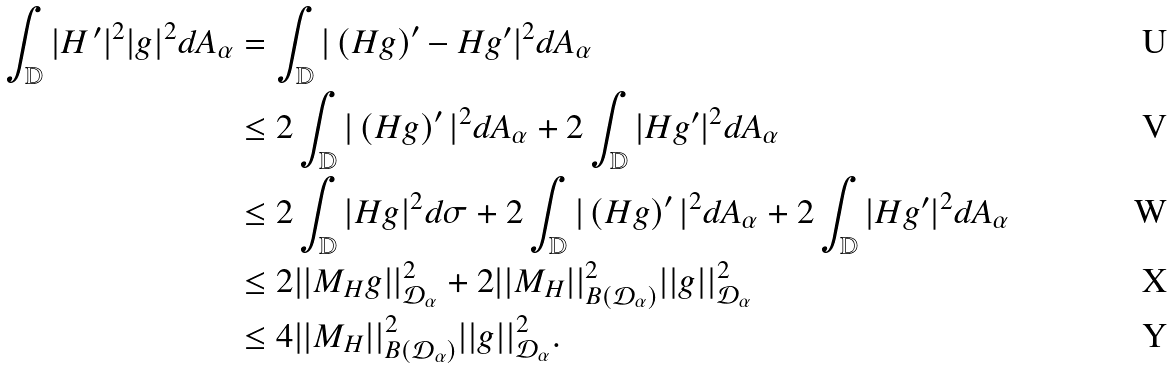<formula> <loc_0><loc_0><loc_500><loc_500>\int _ { \mathbb { D } } | H \, ^ { \prime } | ^ { 2 } | g | ^ { 2 } d A _ { \alpha } & = \int _ { \mathbb { D } } | \left ( H g \right ) ^ { \prime } - H g ^ { \prime } | ^ { 2 } d A _ { \alpha } \\ & \leq 2 \int _ { \mathbb { D } } | \left ( H g \right ) ^ { \prime } | ^ { 2 } d A _ { \alpha } + 2 \int _ { \mathbb { D } } | H g ^ { \prime } | ^ { 2 } d A _ { \alpha } \\ & \leq 2 \int _ { \mathbb { D } } | H g | ^ { 2 } d \sigma + 2 \int _ { \mathbb { D } } | \left ( H g \right ) ^ { \prime } | ^ { 2 } d A _ { \alpha } + 2 \int _ { \mathbb { D } } | H g ^ { \prime } | ^ { 2 } d A _ { \alpha } \\ & \leq 2 | | M _ { H } g | | _ { \mathcal { D } _ { \alpha } } ^ { 2 } + 2 | | M _ { H } | | _ { B \left ( \mathcal { D } _ { \alpha } \right ) } ^ { 2 } | | g | | _ { \mathcal { D } _ { \alpha } } ^ { 2 } \\ & \leq 4 | | M _ { H } | | _ { B \left ( \mathcal { D } _ { \alpha } \right ) } ^ { 2 } | | g | | _ { \mathcal { D } _ { \alpha } } ^ { 2 } .</formula> 